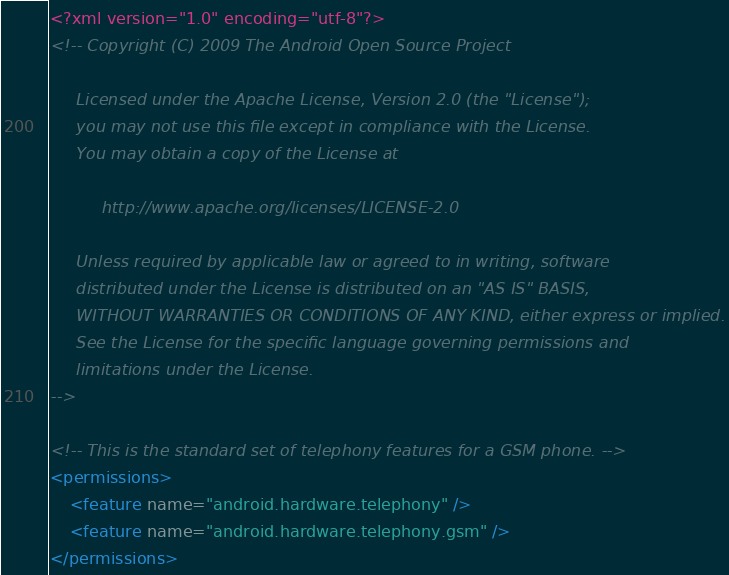<code> <loc_0><loc_0><loc_500><loc_500><_XML_><?xml version="1.0" encoding="utf-8"?>
<!-- Copyright (C) 2009 The Android Open Source Project

     Licensed under the Apache License, Version 2.0 (the "License");
     you may not use this file except in compliance with the License.
     You may obtain a copy of the License at
  
          http://www.apache.org/licenses/LICENSE-2.0
  
     Unless required by applicable law or agreed to in writing, software
     distributed under the License is distributed on an "AS IS" BASIS,
     WITHOUT WARRANTIES OR CONDITIONS OF ANY KIND, either express or implied.
     See the License for the specific language governing permissions and
     limitations under the License.
-->

<!-- This is the standard set of telephony features for a GSM phone. -->
<permissions>
    <feature name="android.hardware.telephony" />
    <feature name="android.hardware.telephony.gsm" />
</permissions>
</code> 